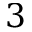<formula> <loc_0><loc_0><loc_500><loc_500>3</formula> 